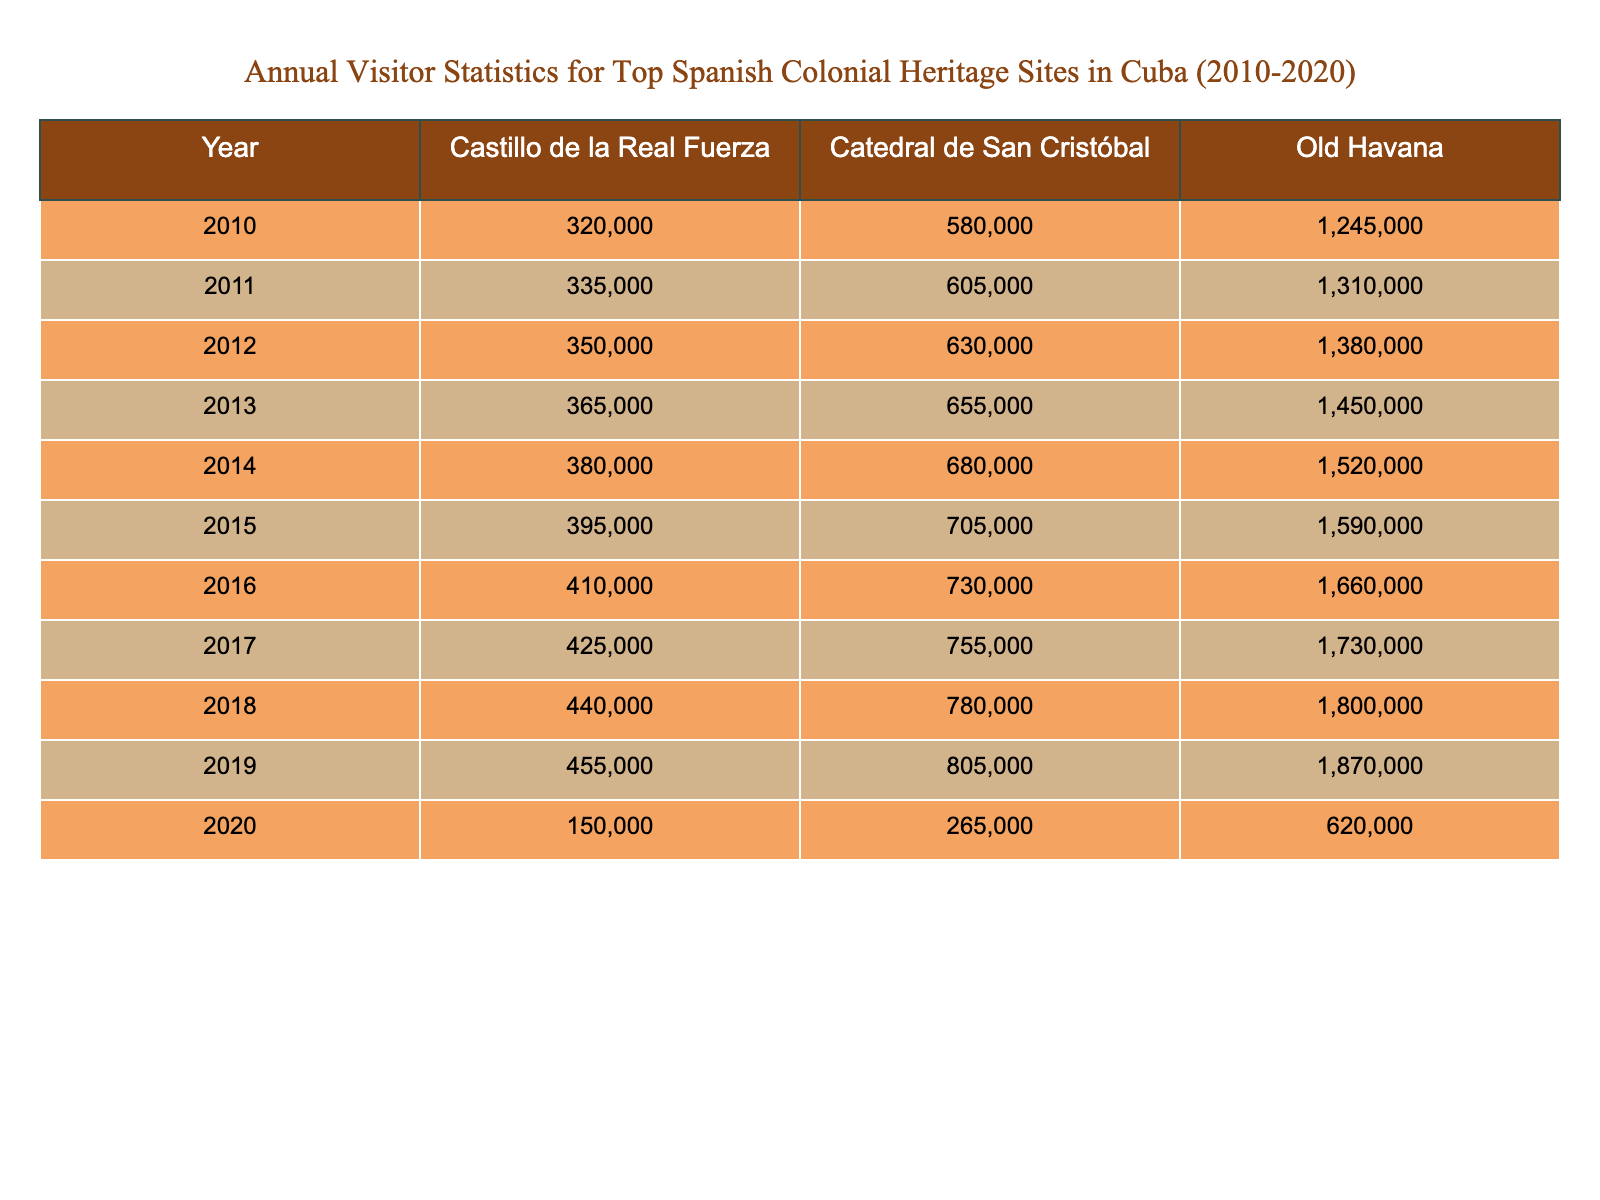What was the total number of visitors to Old Havana in 2015? In 2015, the number of visitors to Old Havana is reported as 1,590,000. Thus, the total number of visitors is straightforwardly taken from the table.
Answer: 1,590,000 Which site had the least number of visitors in 2020? In 2020, the visitor numbers for each site are 620,000 for Old Havana, 150,000 for Castillo de la Real Fuerza, and 265,000 for Catedral de San Cristóbal. The least number is 150,000 for Castillo de la Real Fuerza.
Answer: Castillo de la Real Fuerza What was the increase in visitors to Catedral de San Cristóbal from 2010 to 2019? In 2010, visitors to Catedral de San Cristóbal were 580,000, and in 2019, they were 805,000. The increase is calculated as 805,000 - 580,000 = 225,000.
Answer: 225,000 What year saw the maximum number of visitors to Castillo de la Real Fuerza? By examining the data, the maximum number of visitors to Castillo de la Real Fuerza is found in 2019 at 455,000 visitors, as it consistently increases each year up to that point and then drops in 2020.
Answer: 2019 What was the average number of visitors to Old Havana from 2010 to 2019? The visitor counts for Old Havana from 2010 to 2019 are 1,245,000; 1,310,000; 1,380,000; 1,450,000; 1,520,000; 1,590,000; 1,660,000; 1,730,000; 1,800,000; and 1,870,000. Summing these gives a total of 14,745,000. There are 10 years, so the average is 14,745,000 / 10 = 1,474,500.
Answer: 1,474,500 Did Catedral de San Cristóbal ever exceed 700,000 visitors in any year from 2010 to 2019? Upon checking the data, Catedral de San Cristóbal had visitor numbers exceeding 700,000 in the years 2015 (705,000), 2016 (730,000), 2017 (755,000), 2018 (780,000), and 2019 (805,000). Therefore, the answer is yes.
Answer: Yes Which site showed the largest percentage decrease in visitors from 2019 to 2020? In 2019, Castillo de la Real Fuerza had 455,000 visitors and dropped to 150,000 in 2020, which is a decrease of 305,000. The percentage decrease is calculated as (305,000 / 455,000) * 100 ≈ 67.0%. For Catedral de San Cristóbal, the decrease is (805,000 - 265,000) = 540,000; the percentage is (540,000 / 805,000) * 100 ≈ 67.1%. The calculations show that Catedral de San Cristóbal has a larger percentage decrease than Castillo de la Real Fuerza.
Answer: Catedral de San Cristóbal What was the combined total number of visitors for all sites in 2014? For 2014, the visitor counts are Old Havana: 1,520,000, Castillo de la Real Fuerza: 380,000, and Catedral de San Cristóbal: 680,000. Adding these gives 1,520,000 + 380,000 + 680,000 = 2,580,000.
Answer: 2,580,000 How many years saw a decline in visitors for Old Havana? In 2020, Old Havana had 620,000 visitors, and the previous year, 2019, had 1,870,000, indicating a decline. All previous years showed an increase. Thus, there was only one year (2020) where the visitors decreased.
Answer: 1 Which site consistently had the highest number of visitors each year from 2010 to 2019? Observing the data for each year, Old Havana had the highest number of visitors in every year from 2010 to 2019, surpassing the visitors of Castillo de la Real Fuerza and Catedral de San Cristóbal.
Answer: Old Havana 